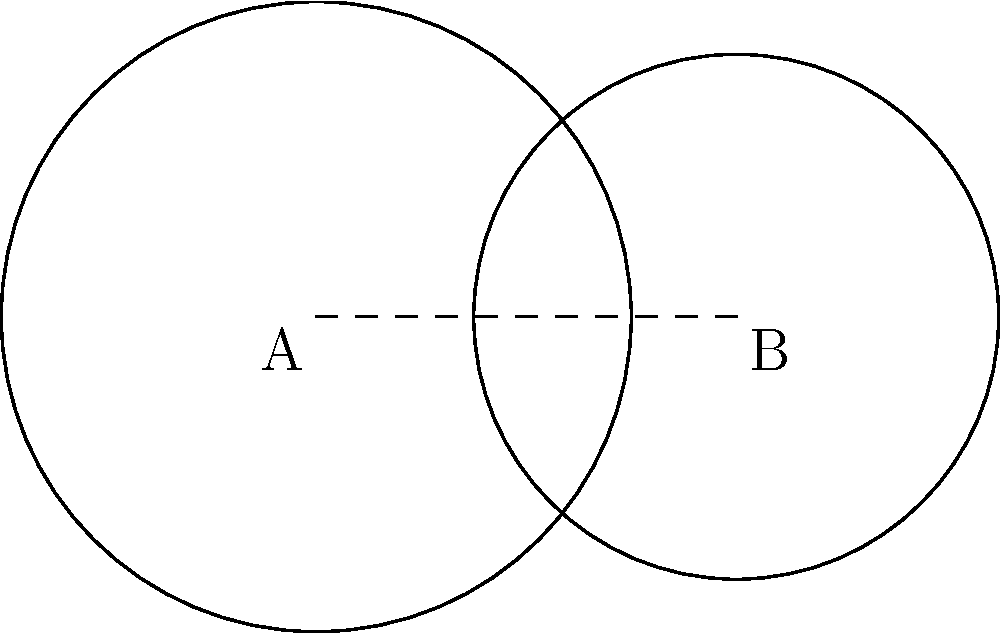In a volcanic deposit, two circular mineral-rich zones are identified. Zone A has a radius of 3 km, and Zone B has a radius of 2.5 km. The centers of these zones are 4 km apart. Calculate the area of the overlapping region where both mineral-rich zones intersect. Round your answer to the nearest 0.01 km². To find the area of overlap between two circles, we can use the following steps:

1) First, we need to calculate the distance $d$ from the center of each circle to the chord of intersection:

   $d_A = \frac{r_A^2 - r_B^2 + c^2}{2c}$ for circle A
   $d_B = c - d_A$ for circle B

   Where $r_A = 3$ km, $r_B = 2.5$ km, and $c = 4$ km (distance between centers)

2) Calculate $d_A$:
   $d_A = \frac{3^2 - 2.5^2 + 4^2}{2(4)} = 2.28125$ km

3) Calculate $d_B$:
   $d_B = 4 - 2.28125 = 1.71875$ km

4) Now, calculate the central angle $\theta$ for each circle:
   $\theta_A = 2 \arccos(\frac{d_A}{r_A})$
   $\theta_B = 2 \arccos(\frac{d_B}{r_B})$

5) Calculate $\theta_A$ and $\theta_B$:
   $\theta_A = 2 \arccos(\frac{2.28125}{3}) = 2.0944$ radians
   $\theta_B = 2 \arccos(\frac{1.71875}{2.5}) = 2.4981$ radians

6) The area of overlap is the sum of the circular sectors minus the area of the rhombus:
   $Area = \frac{1}{2}r_A^2\theta_A + \frac{1}{2}r_B^2\theta_B - (r_A^2\sin(\frac{\theta_A}{2}) + r_B^2\sin(\frac{\theta_B}{2}))$

7) Plugging in the values:
   $Area = \frac{1}{2}(3^2)(2.0944) + \frac{1}{2}(2.5^2)(2.4981) - (3^2\sin(1.0472) + 2.5^2\sin(1.24905))$
   $= 9.4248 + 7.8066 - (7.7942 + 5.4288)$
   $= 4.0084$ km²

8) Rounding to the nearest 0.01 km²: 4.01 km²
Answer: 4.01 km² 